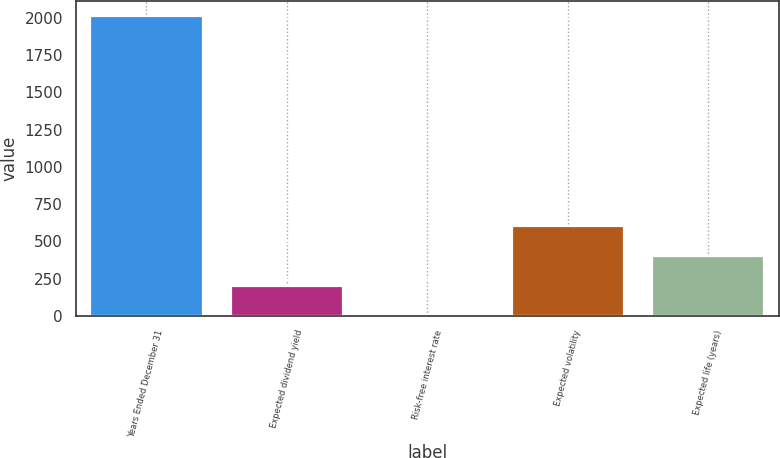<chart> <loc_0><loc_0><loc_500><loc_500><bar_chart><fcel>Years Ended December 31<fcel>Expected dividend yield<fcel>Risk-free interest rate<fcel>Expected volatility<fcel>Expected life (years)<nl><fcel>2016<fcel>202.86<fcel>1.4<fcel>605.78<fcel>404.32<nl></chart> 